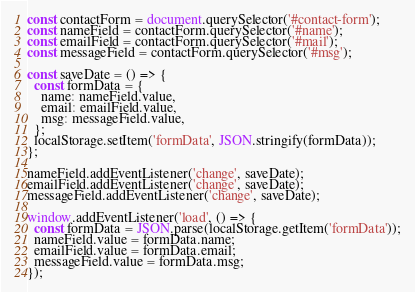<code> <loc_0><loc_0><loc_500><loc_500><_JavaScript_>const contactForm = document.querySelector('#contact-form');
const nameField = contactForm.querySelector('#name');
const emailField = contactForm.querySelector('#mail');
const messageField = contactForm.querySelector('#msg');

const saveDate = () => {
  const formData = {
    name: nameField.value,
    email: emailField.value,
    msg: messageField.value,
  };
  localStorage.setItem('formData', JSON.stringify(formData));
};

nameField.addEventListener('change', saveDate);
emailField.addEventListener('change', saveDate);
messageField.addEventListener('change', saveDate);

window.addEventListener('load', () => {
  const formData = JSON.parse(localStorage.getItem('formData'));
  nameField.value = formData.name;
  emailField.value = formData.email;
  messageField.value = formData.msg;
});
</code> 